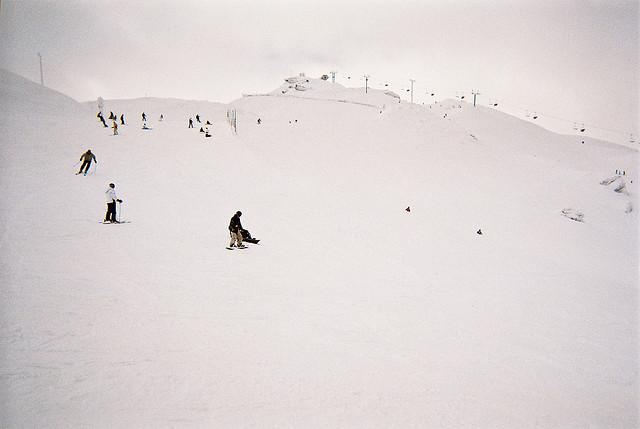What kind of sport are the people pictured above playing? Please explain your reasoning. skiing. The people are using skis. 